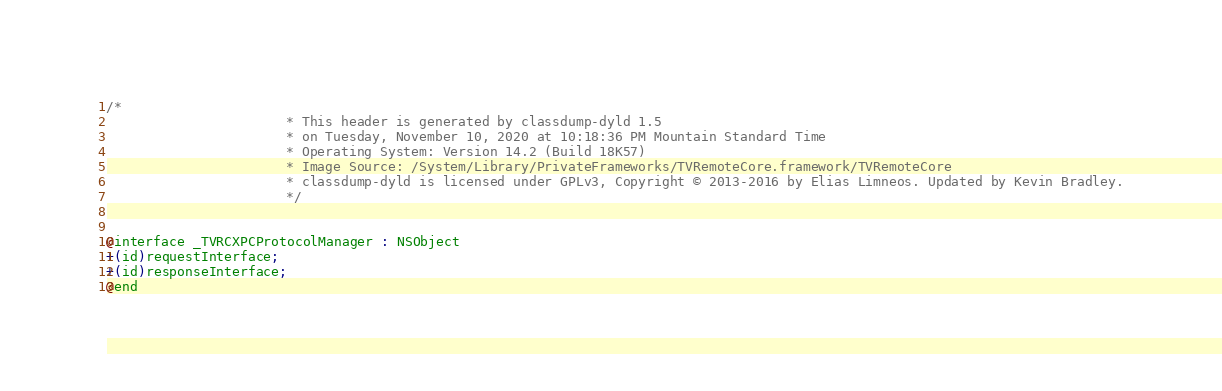Convert code to text. <code><loc_0><loc_0><loc_500><loc_500><_C_>/*
                       * This header is generated by classdump-dyld 1.5
                       * on Tuesday, November 10, 2020 at 10:18:36 PM Mountain Standard Time
                       * Operating System: Version 14.2 (Build 18K57)
                       * Image Source: /System/Library/PrivateFrameworks/TVRemoteCore.framework/TVRemoteCore
                       * classdump-dyld is licensed under GPLv3, Copyright © 2013-2016 by Elias Limneos. Updated by Kevin Bradley.
                       */


@interface _TVRCXPCProtocolManager : NSObject
+(id)requestInterface;
+(id)responseInterface;
@end

</code> 